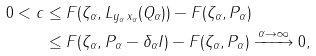<formula> <loc_0><loc_0><loc_500><loc_500>0 < c & \leq F ( \zeta _ { \alpha } , L _ { y _ { \alpha } \, x _ { \alpha } } ( Q _ { \alpha } ) ) - F ( \zeta _ { \alpha } , P _ { \alpha } ) \\ & \leq F ( \zeta _ { \alpha } , P _ { \alpha } - \delta _ { \alpha } I ) - F ( \zeta _ { \alpha } , P _ { \alpha } ) \xrightarrow { \alpha \to \infty } 0 ,</formula> 